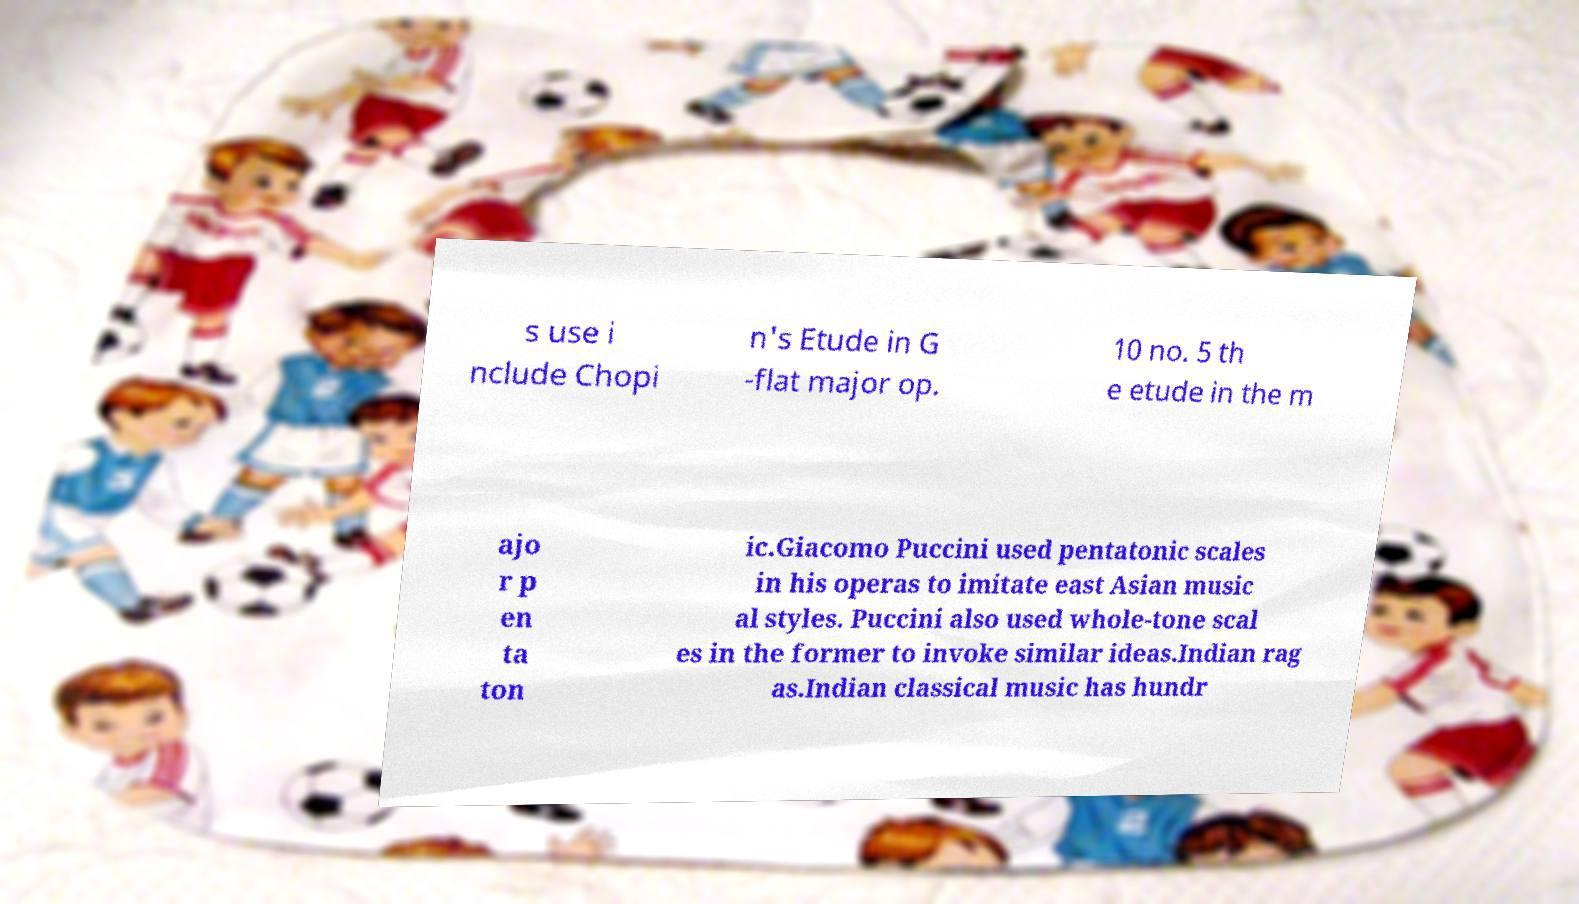What messages or text are displayed in this image? I need them in a readable, typed format. s use i nclude Chopi n's Etude in G -flat major op. 10 no. 5 th e etude in the m ajo r p en ta ton ic.Giacomo Puccini used pentatonic scales in his operas to imitate east Asian music al styles. Puccini also used whole-tone scal es in the former to invoke similar ideas.Indian rag as.Indian classical music has hundr 